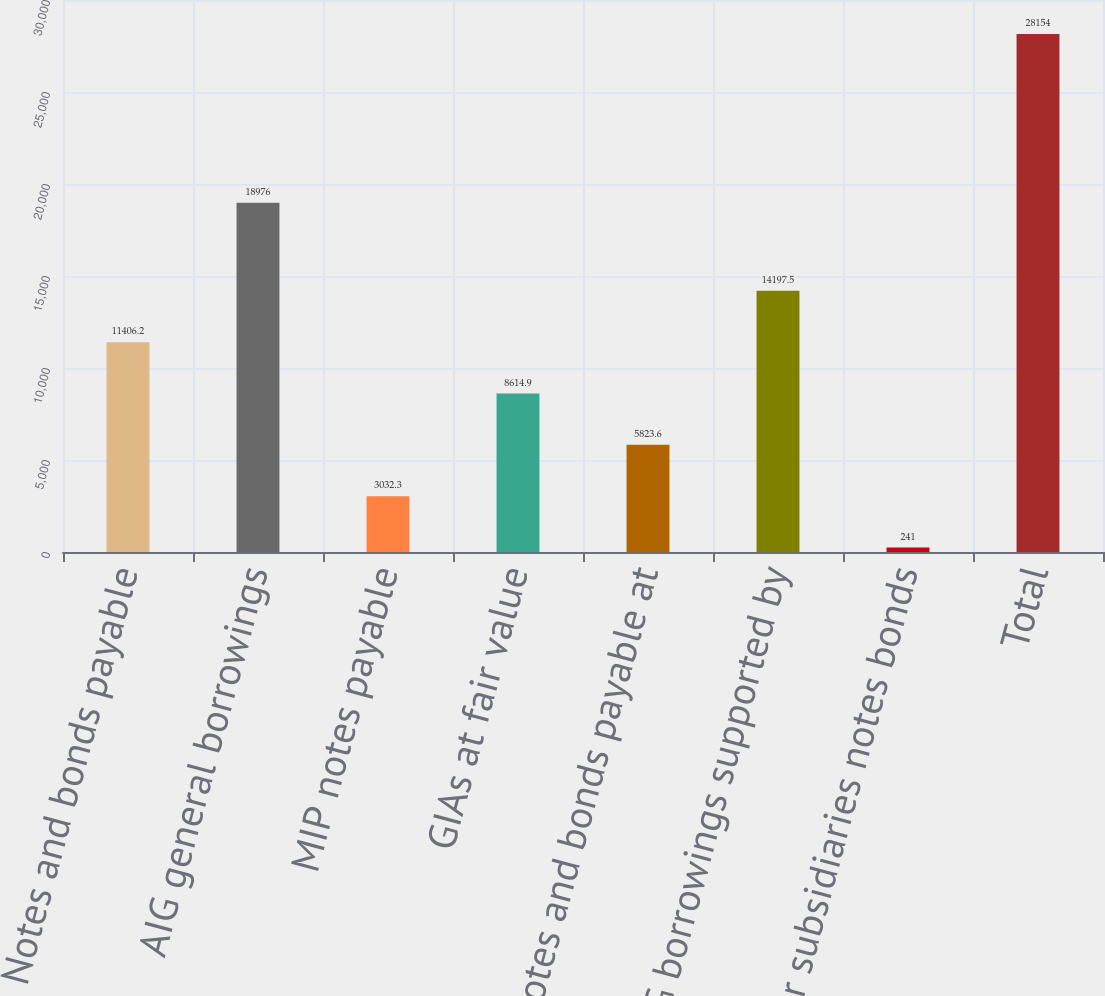<chart> <loc_0><loc_0><loc_500><loc_500><bar_chart><fcel>Notes and bonds payable<fcel>AIG general borrowings<fcel>MIP notes payable<fcel>GIAs at fair value<fcel>Notes and bonds payable at<fcel>AIG borrowings supported by<fcel>Other subsidiaries notes bonds<fcel>Total<nl><fcel>11406.2<fcel>18976<fcel>3032.3<fcel>8614.9<fcel>5823.6<fcel>14197.5<fcel>241<fcel>28154<nl></chart> 